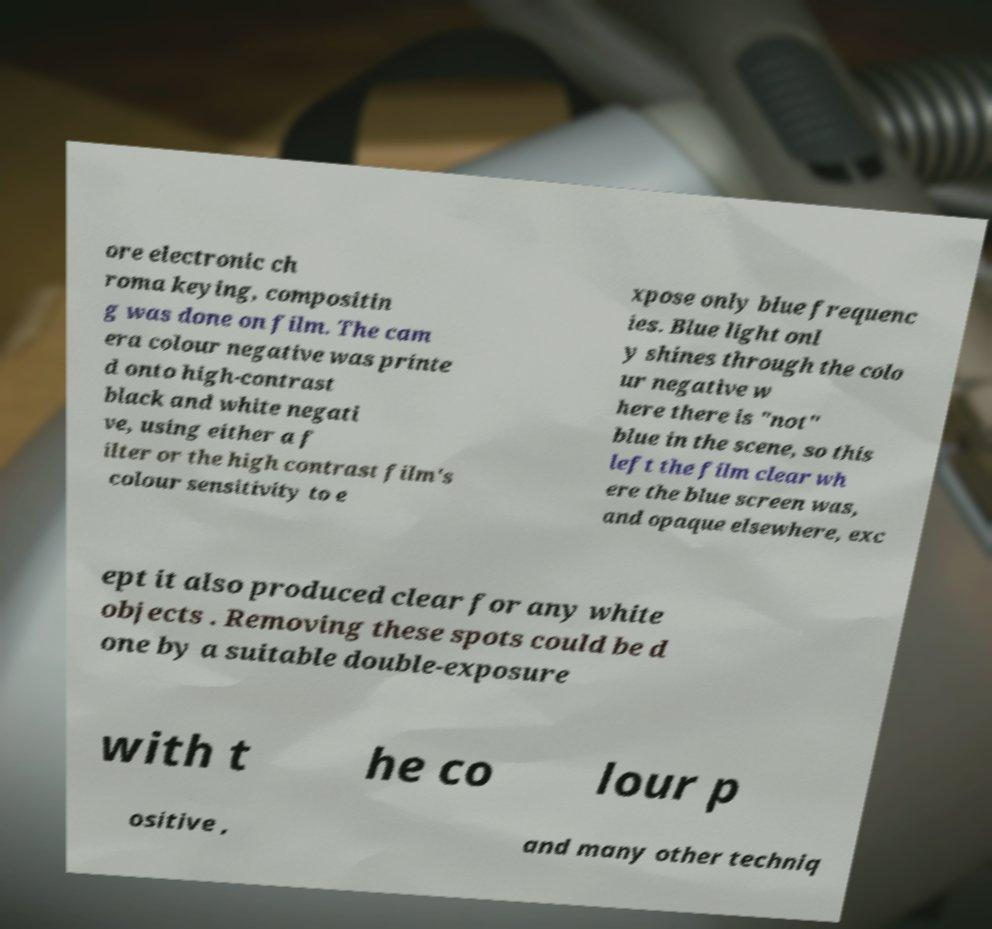What messages or text are displayed in this image? I need them in a readable, typed format. ore electronic ch roma keying, compositin g was done on film. The cam era colour negative was printe d onto high-contrast black and white negati ve, using either a f ilter or the high contrast film's colour sensitivity to e xpose only blue frequenc ies. Blue light onl y shines through the colo ur negative w here there is "not" blue in the scene, so this left the film clear wh ere the blue screen was, and opaque elsewhere, exc ept it also produced clear for any white objects . Removing these spots could be d one by a suitable double-exposure with t he co lour p ositive , and many other techniq 